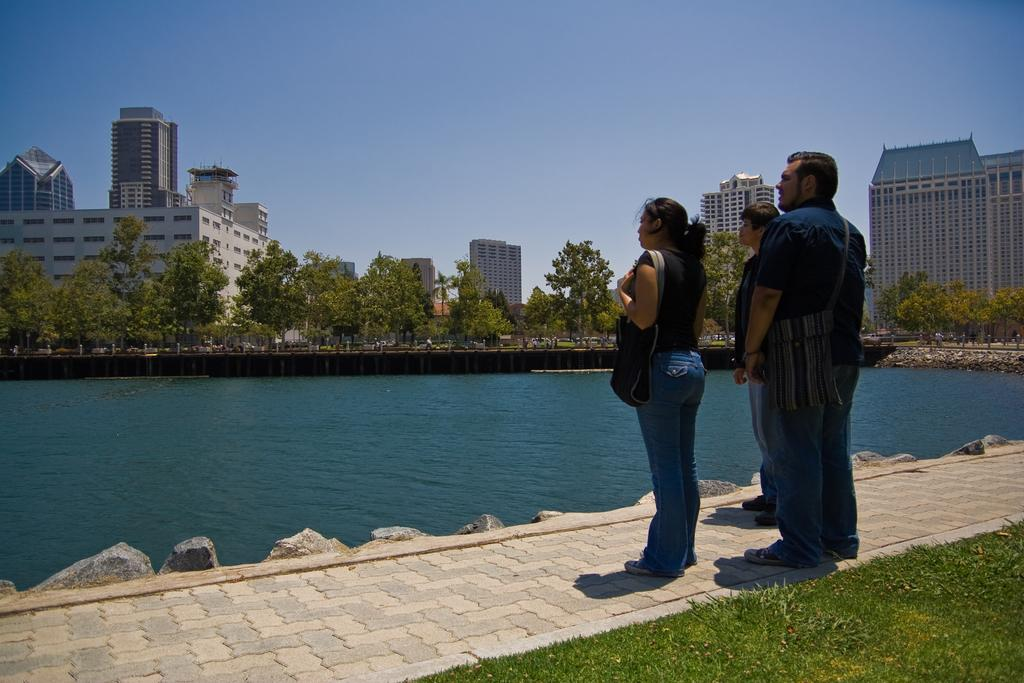What are the people in the image doing? The group of people is standing on the ground. Can you describe the woman's attire in the image? The woman is wearing a bag. What can be seen in the background of the image? There are trees, buildings, a lake, and the sky visible in the background. What time does the grandmother arrive in the image? There is no mention of a grandmother in the image, so it is impossible to determine when she might arrive. 